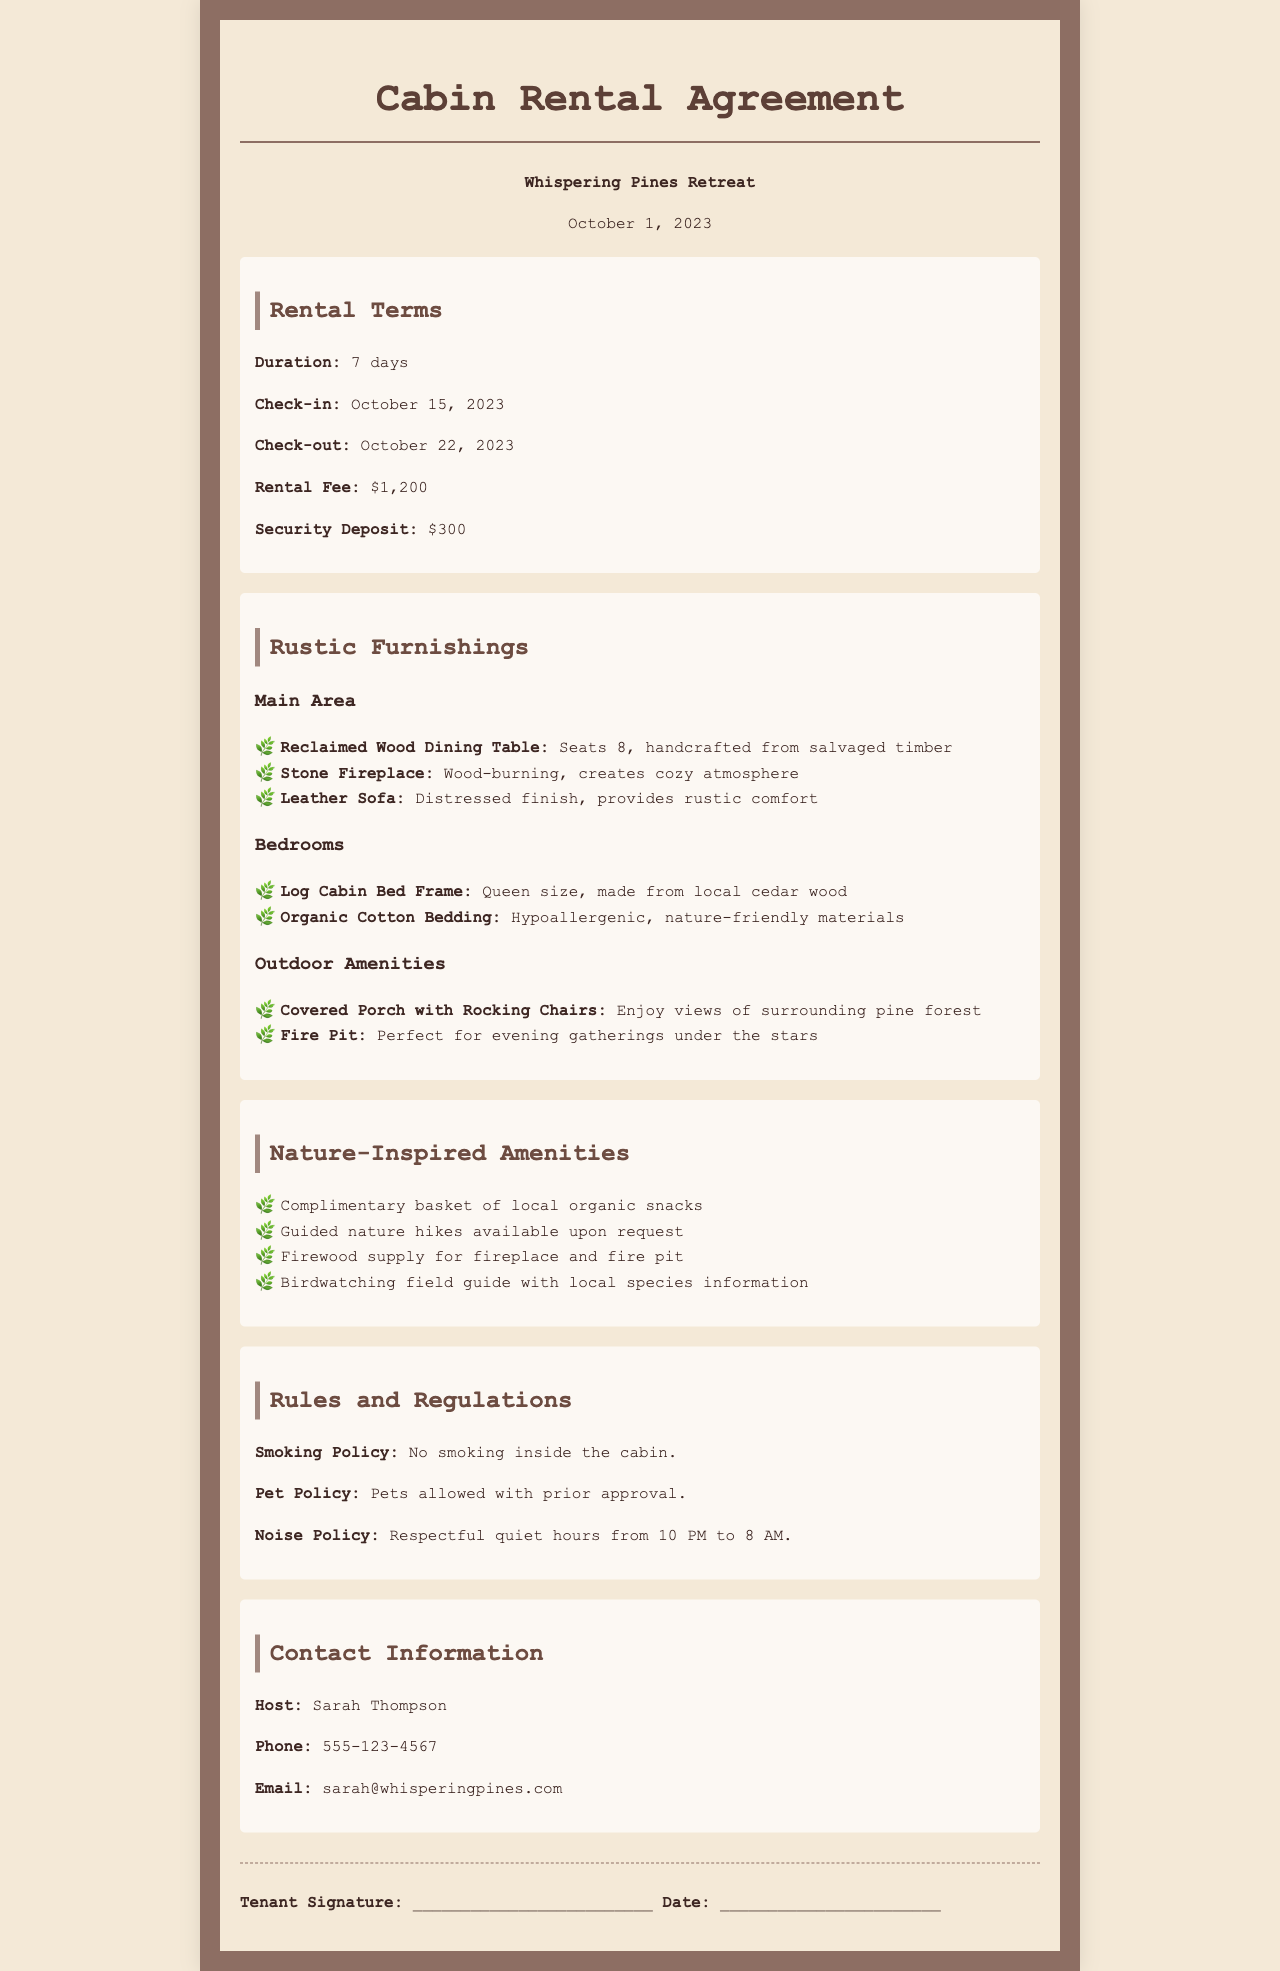What is the rental fee? The rental fee is listed in the document under the Rental Terms section.
Answer: $1,200 What type of sofa is provided? The specific type of sofa is mentioned in the Rustic Furnishings section under Main Area.
Answer: Leather Sofa What is the check-out date? The check-out date is given in the Rental Terms section of the document.
Answer: October 22, 2023 How many people can the dining table seat? The seating capacity of the dining table is stated in the Rustic Furnishings section under Main Area.
Answer: 8 What nature-inspired amenity is included with snacks? The nature-inspired amenities include a specific item related to snacks.
Answer: Complimentary basket of local organic snacks What is the smoking policy? The smoking policy is stated in the Rules and Regulations section of the document.
Answer: No smoking inside the cabin Who is the host of Whispering Pines Retreat? The host's name can be found in the Contact Information section.
Answer: Sarah Thompson Is there a pet policy in the cabin rental agreement? The document includes rules regarding pets in the Rules and Regulations section.
Answer: Pets allowed with prior approval 